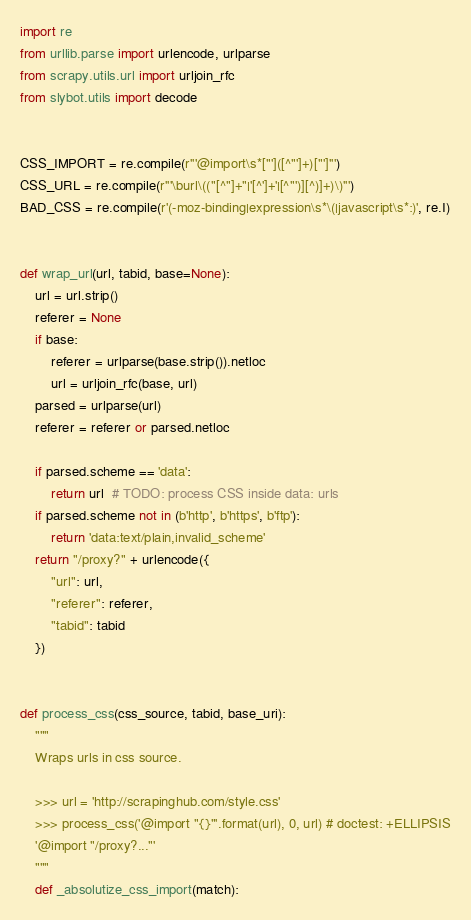<code> <loc_0><loc_0><loc_500><loc_500><_Python_>import re
from urllib.parse import urlencode, urlparse
from scrapy.utils.url import urljoin_rfc
from slybot.utils import decode


CSS_IMPORT = re.compile(r'''@import\s*["']([^"']+)["']''')
CSS_URL = re.compile(r'''\burl\(("[^"]+"|'[^']+'|[^"')][^)]+)\)''')
BAD_CSS = re.compile(r'(-moz-binding|expression\s*\(|javascript\s*:)', re.I)


def wrap_url(url, tabid, base=None):
    url = url.strip()
    referer = None
    if base:
        referer = urlparse(base.strip()).netloc
        url = urljoin_rfc(base, url)
    parsed = urlparse(url)
    referer = referer or parsed.netloc

    if parsed.scheme == 'data':
        return url  # TODO: process CSS inside data: urls
    if parsed.scheme not in (b'http', b'https', b'ftp'):
        return 'data:text/plain,invalid_scheme'
    return "/proxy?" + urlencode({
        "url": url,
        "referer": referer,
        "tabid": tabid
    })


def process_css(css_source, tabid, base_uri):
    """
    Wraps urls in css source.

    >>> url = 'http://scrapinghub.com/style.css'
    >>> process_css('@import "{}"'.format(url), 0, url) # doctest: +ELLIPSIS
    '@import "/proxy?..."'
    """
    def _absolutize_css_import(match):</code> 